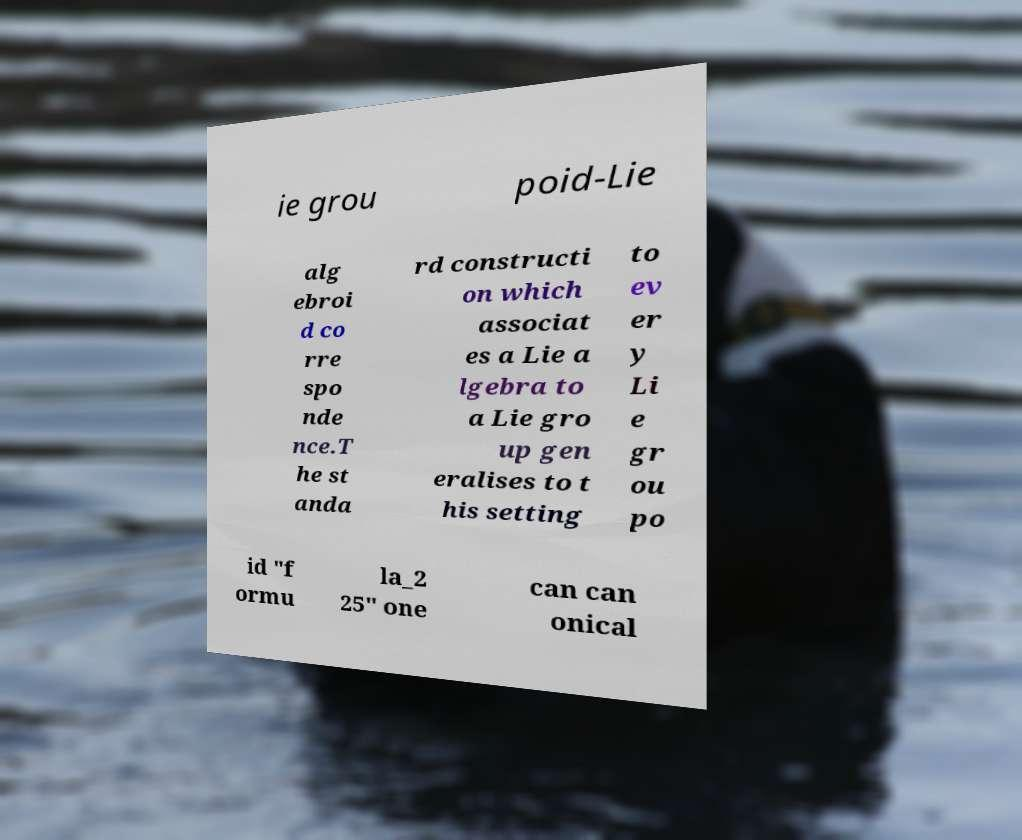I need the written content from this picture converted into text. Can you do that? ie grou poid-Lie alg ebroi d co rre spo nde nce.T he st anda rd constructi on which associat es a Lie a lgebra to a Lie gro up gen eralises to t his setting to ev er y Li e gr ou po id "f ormu la_2 25" one can can onical 